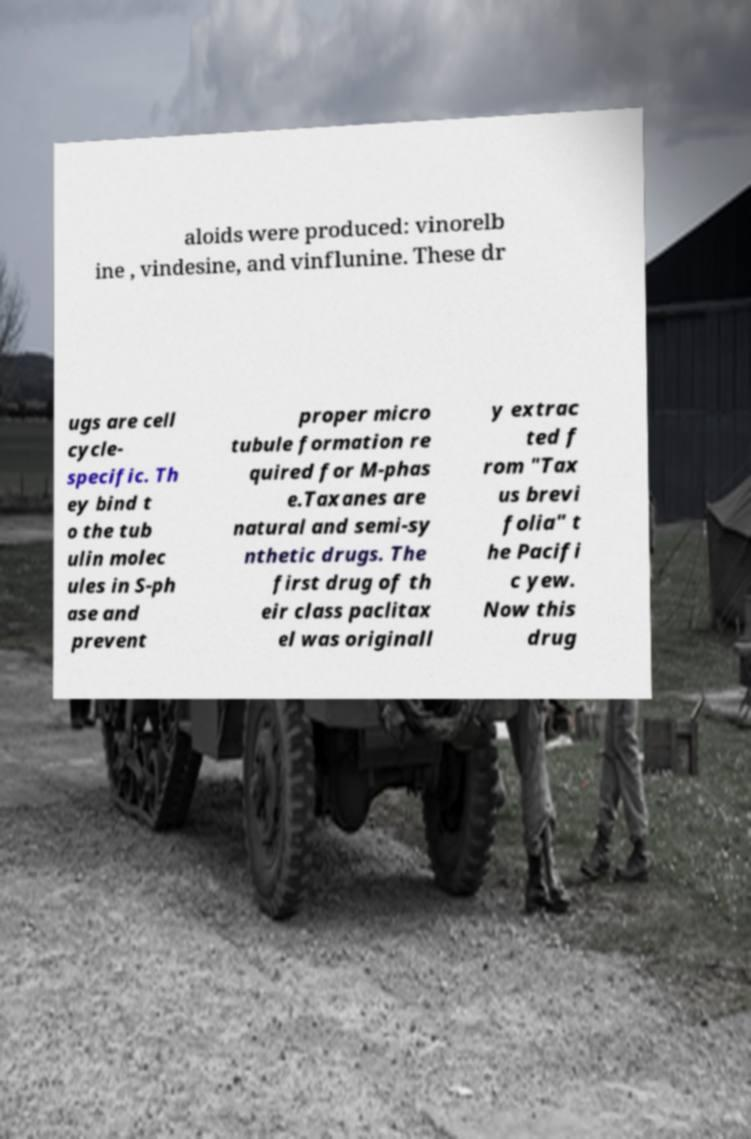Could you extract and type out the text from this image? aloids were produced: vinorelb ine , vindesine, and vinflunine. These dr ugs are cell cycle- specific. Th ey bind t o the tub ulin molec ules in S-ph ase and prevent proper micro tubule formation re quired for M-phas e.Taxanes are natural and semi-sy nthetic drugs. The first drug of th eir class paclitax el was originall y extrac ted f rom "Tax us brevi folia" t he Pacifi c yew. Now this drug 